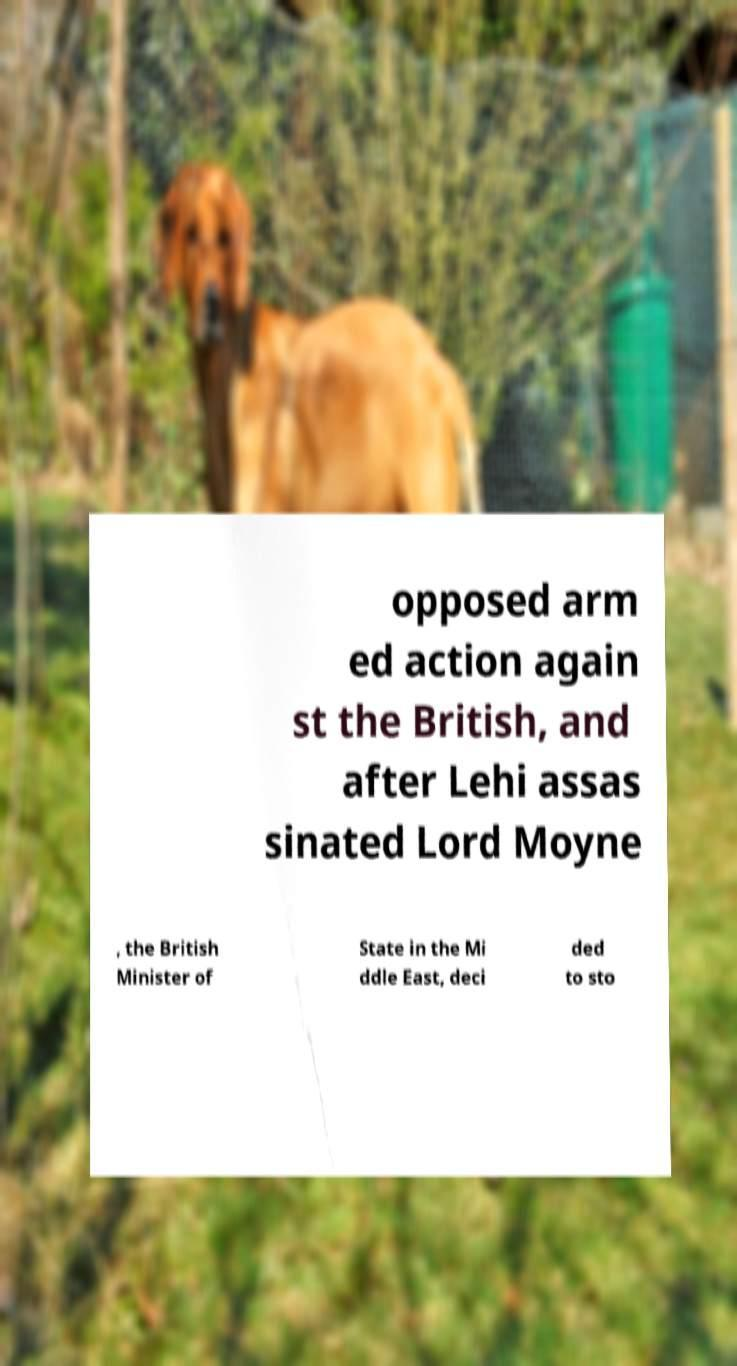What messages or text are displayed in this image? I need them in a readable, typed format. opposed arm ed action again st the British, and after Lehi assas sinated Lord Moyne , the British Minister of State in the Mi ddle East, deci ded to sto 